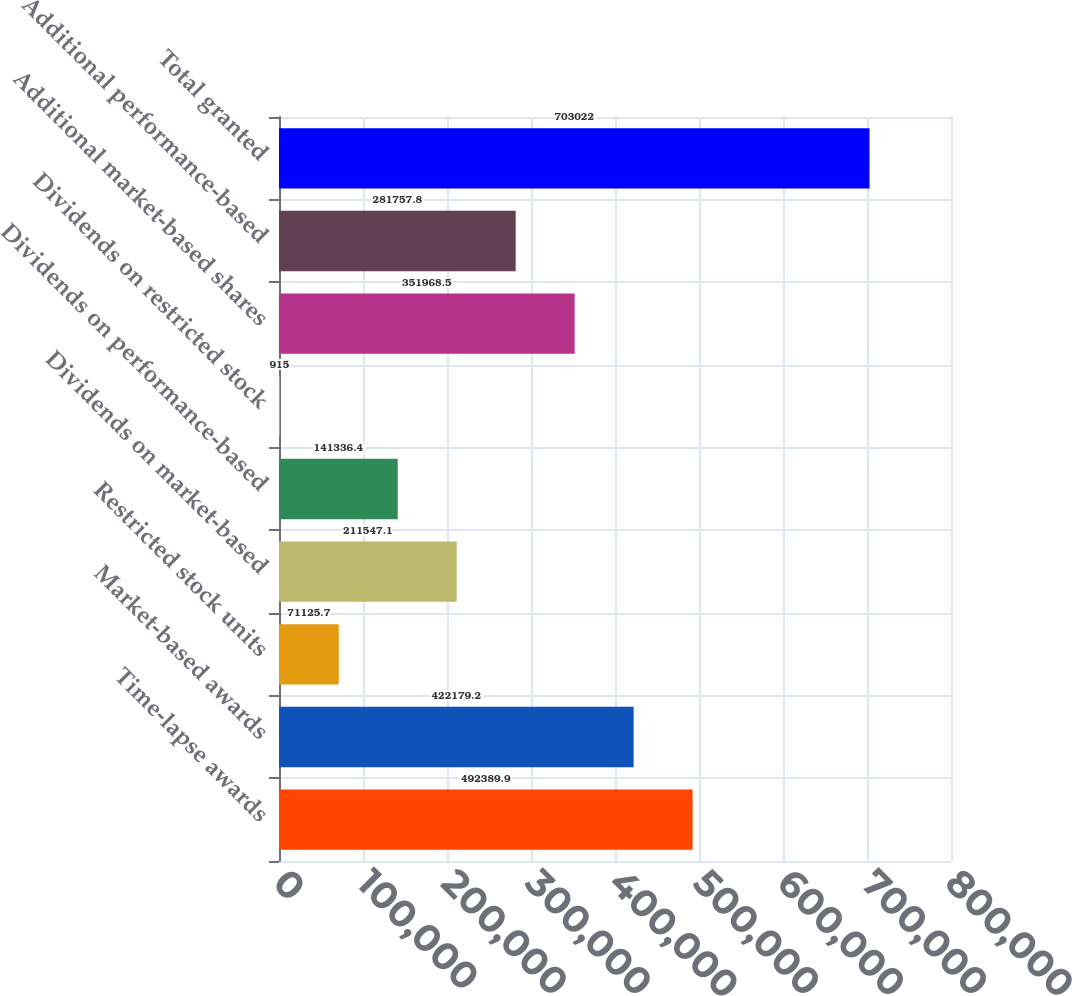Convert chart. <chart><loc_0><loc_0><loc_500><loc_500><bar_chart><fcel>Time-lapse awards<fcel>Market-based awards<fcel>Restricted stock units<fcel>Dividends on market-based<fcel>Dividends on performance-based<fcel>Dividends on restricted stock<fcel>Additional market-based shares<fcel>Additional performance-based<fcel>Total granted<nl><fcel>492390<fcel>422179<fcel>71125.7<fcel>211547<fcel>141336<fcel>915<fcel>351968<fcel>281758<fcel>703022<nl></chart> 